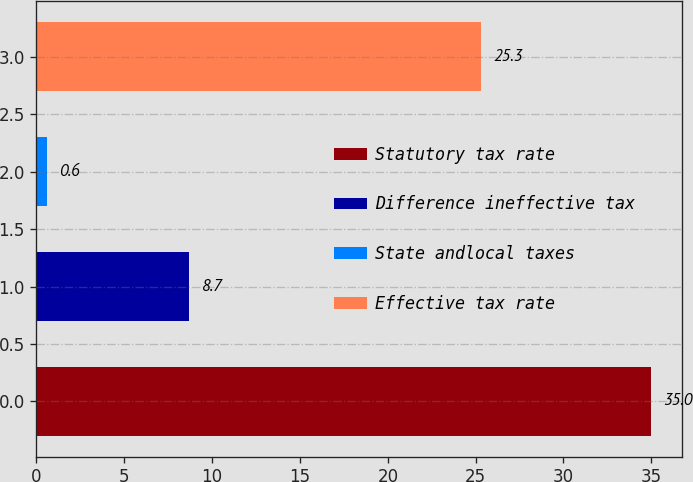Convert chart. <chart><loc_0><loc_0><loc_500><loc_500><bar_chart><fcel>Statutory tax rate<fcel>Difference ineffective tax<fcel>State andlocal taxes<fcel>Effective tax rate<nl><fcel>35<fcel>8.7<fcel>0.6<fcel>25.3<nl></chart> 